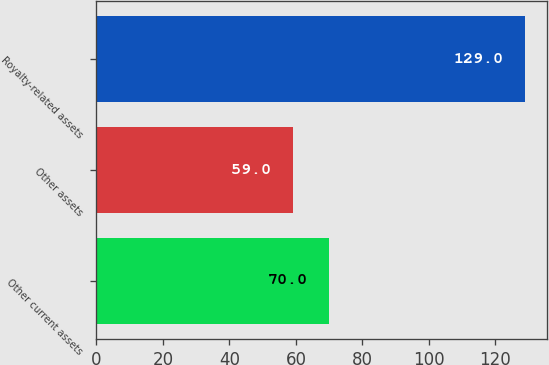<chart> <loc_0><loc_0><loc_500><loc_500><bar_chart><fcel>Other current assets<fcel>Other assets<fcel>Royalty-related assets<nl><fcel>70<fcel>59<fcel>129<nl></chart> 